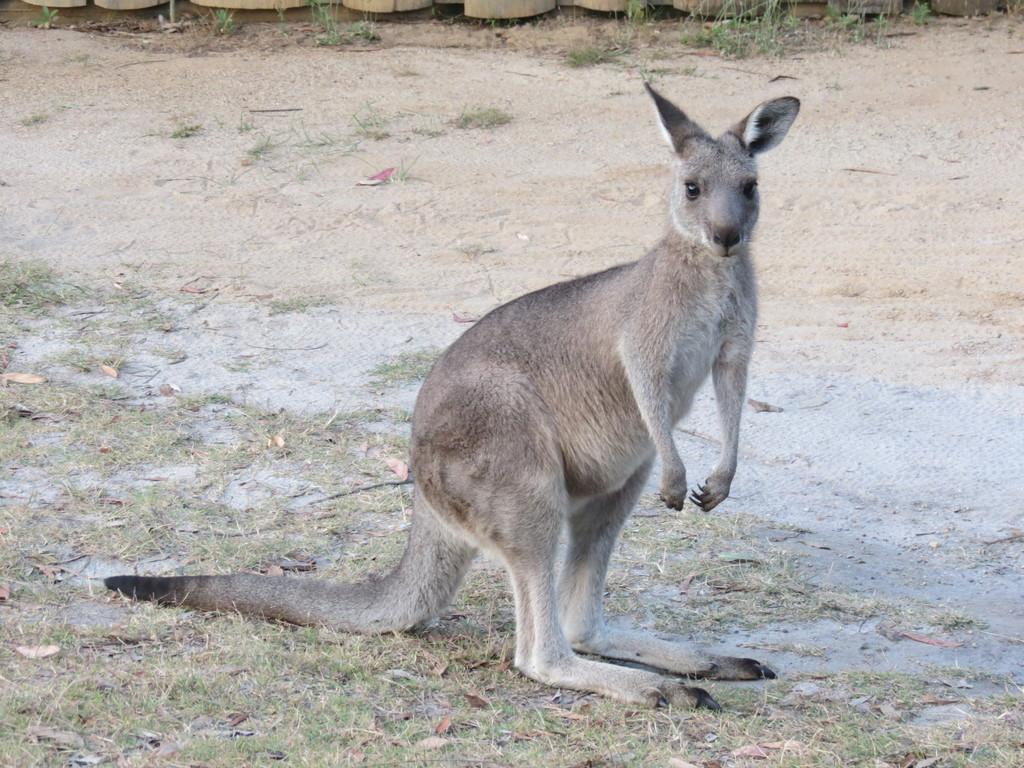Please provide a concise description of this image. In the foreground of the picture there are dry leaves, grass and a kangaroo. In the middle of the picture there is sand. At the top we can see some wooden objects and grass. 